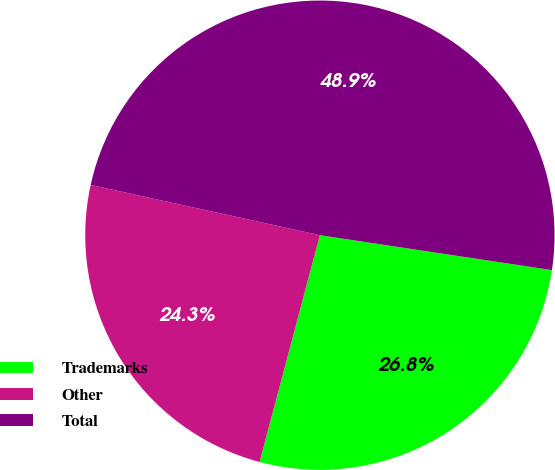Convert chart to OTSL. <chart><loc_0><loc_0><loc_500><loc_500><pie_chart><fcel>Trademarks<fcel>Other<fcel>Total<nl><fcel>26.76%<fcel>24.3%<fcel>48.94%<nl></chart> 